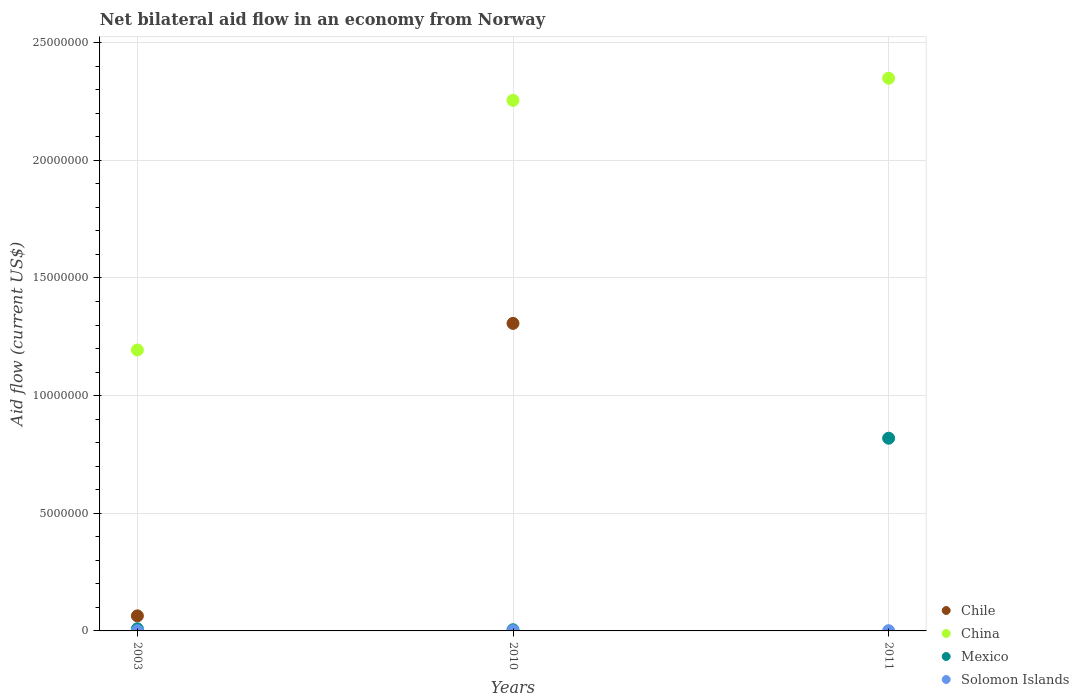Is the number of dotlines equal to the number of legend labels?
Make the answer very short. No. What is the net bilateral aid flow in Solomon Islands in 2003?
Offer a terse response. 10000. Across all years, what is the minimum net bilateral aid flow in Solomon Islands?
Ensure brevity in your answer.  10000. In which year was the net bilateral aid flow in China maximum?
Make the answer very short. 2011. What is the total net bilateral aid flow in China in the graph?
Provide a short and direct response. 5.80e+07. What is the difference between the net bilateral aid flow in China in 2011 and the net bilateral aid flow in Mexico in 2003?
Offer a very short reply. 2.34e+07. What is the average net bilateral aid flow in Solomon Islands per year?
Provide a succinct answer. 10000. What is the ratio of the net bilateral aid flow in Solomon Islands in 2003 to that in 2010?
Keep it short and to the point. 1. What is the difference between the highest and the lowest net bilateral aid flow in Chile?
Offer a very short reply. 1.31e+07. In how many years, is the net bilateral aid flow in Chile greater than the average net bilateral aid flow in Chile taken over all years?
Give a very brief answer. 1. Is the sum of the net bilateral aid flow in Chile in 2003 and 2010 greater than the maximum net bilateral aid flow in Mexico across all years?
Provide a short and direct response. Yes. Is it the case that in every year, the sum of the net bilateral aid flow in China and net bilateral aid flow in Solomon Islands  is greater than the sum of net bilateral aid flow in Mexico and net bilateral aid flow in Chile?
Your answer should be very brief. Yes. Is it the case that in every year, the sum of the net bilateral aid flow in Mexico and net bilateral aid flow in Solomon Islands  is greater than the net bilateral aid flow in China?
Make the answer very short. No. Is the net bilateral aid flow in Mexico strictly greater than the net bilateral aid flow in China over the years?
Offer a very short reply. No. How many dotlines are there?
Your answer should be very brief. 4. What is the difference between two consecutive major ticks on the Y-axis?
Keep it short and to the point. 5.00e+06. Where does the legend appear in the graph?
Ensure brevity in your answer.  Bottom right. How are the legend labels stacked?
Make the answer very short. Vertical. What is the title of the graph?
Your response must be concise. Net bilateral aid flow in an economy from Norway. What is the label or title of the X-axis?
Offer a very short reply. Years. What is the label or title of the Y-axis?
Provide a succinct answer. Aid flow (current US$). What is the Aid flow (current US$) of Chile in 2003?
Your response must be concise. 6.40e+05. What is the Aid flow (current US$) in China in 2003?
Keep it short and to the point. 1.19e+07. What is the Aid flow (current US$) of Chile in 2010?
Give a very brief answer. 1.31e+07. What is the Aid flow (current US$) in China in 2010?
Your answer should be very brief. 2.26e+07. What is the Aid flow (current US$) in Mexico in 2010?
Offer a very short reply. 5.00e+04. What is the Aid flow (current US$) of China in 2011?
Keep it short and to the point. 2.35e+07. What is the Aid flow (current US$) in Mexico in 2011?
Make the answer very short. 8.19e+06. What is the Aid flow (current US$) in Solomon Islands in 2011?
Ensure brevity in your answer.  10000. Across all years, what is the maximum Aid flow (current US$) of Chile?
Offer a terse response. 1.31e+07. Across all years, what is the maximum Aid flow (current US$) of China?
Give a very brief answer. 2.35e+07. Across all years, what is the maximum Aid flow (current US$) in Mexico?
Offer a very short reply. 8.19e+06. Across all years, what is the maximum Aid flow (current US$) in Solomon Islands?
Your answer should be compact. 10000. Across all years, what is the minimum Aid flow (current US$) of China?
Offer a very short reply. 1.19e+07. Across all years, what is the minimum Aid flow (current US$) in Solomon Islands?
Your response must be concise. 10000. What is the total Aid flow (current US$) of Chile in the graph?
Ensure brevity in your answer.  1.37e+07. What is the total Aid flow (current US$) of China in the graph?
Provide a short and direct response. 5.80e+07. What is the total Aid flow (current US$) of Mexico in the graph?
Give a very brief answer. 8.33e+06. What is the total Aid flow (current US$) in Solomon Islands in the graph?
Offer a terse response. 3.00e+04. What is the difference between the Aid flow (current US$) of Chile in 2003 and that in 2010?
Provide a succinct answer. -1.24e+07. What is the difference between the Aid flow (current US$) of China in 2003 and that in 2010?
Your response must be concise. -1.06e+07. What is the difference between the Aid flow (current US$) in Solomon Islands in 2003 and that in 2010?
Provide a short and direct response. 0. What is the difference between the Aid flow (current US$) in China in 2003 and that in 2011?
Your answer should be very brief. -1.16e+07. What is the difference between the Aid flow (current US$) of Mexico in 2003 and that in 2011?
Offer a very short reply. -8.10e+06. What is the difference between the Aid flow (current US$) in China in 2010 and that in 2011?
Your answer should be very brief. -9.40e+05. What is the difference between the Aid flow (current US$) in Mexico in 2010 and that in 2011?
Give a very brief answer. -8.14e+06. What is the difference between the Aid flow (current US$) in Solomon Islands in 2010 and that in 2011?
Offer a terse response. 0. What is the difference between the Aid flow (current US$) in Chile in 2003 and the Aid flow (current US$) in China in 2010?
Provide a succinct answer. -2.19e+07. What is the difference between the Aid flow (current US$) of Chile in 2003 and the Aid flow (current US$) of Mexico in 2010?
Offer a very short reply. 5.90e+05. What is the difference between the Aid flow (current US$) of Chile in 2003 and the Aid flow (current US$) of Solomon Islands in 2010?
Your answer should be very brief. 6.30e+05. What is the difference between the Aid flow (current US$) in China in 2003 and the Aid flow (current US$) in Mexico in 2010?
Your answer should be compact. 1.19e+07. What is the difference between the Aid flow (current US$) of China in 2003 and the Aid flow (current US$) of Solomon Islands in 2010?
Your response must be concise. 1.19e+07. What is the difference between the Aid flow (current US$) in Mexico in 2003 and the Aid flow (current US$) in Solomon Islands in 2010?
Offer a very short reply. 8.00e+04. What is the difference between the Aid flow (current US$) in Chile in 2003 and the Aid flow (current US$) in China in 2011?
Give a very brief answer. -2.28e+07. What is the difference between the Aid flow (current US$) of Chile in 2003 and the Aid flow (current US$) of Mexico in 2011?
Keep it short and to the point. -7.55e+06. What is the difference between the Aid flow (current US$) of Chile in 2003 and the Aid flow (current US$) of Solomon Islands in 2011?
Ensure brevity in your answer.  6.30e+05. What is the difference between the Aid flow (current US$) of China in 2003 and the Aid flow (current US$) of Mexico in 2011?
Your answer should be compact. 3.75e+06. What is the difference between the Aid flow (current US$) of China in 2003 and the Aid flow (current US$) of Solomon Islands in 2011?
Keep it short and to the point. 1.19e+07. What is the difference between the Aid flow (current US$) of Mexico in 2003 and the Aid flow (current US$) of Solomon Islands in 2011?
Offer a very short reply. 8.00e+04. What is the difference between the Aid flow (current US$) of Chile in 2010 and the Aid flow (current US$) of China in 2011?
Give a very brief answer. -1.04e+07. What is the difference between the Aid flow (current US$) of Chile in 2010 and the Aid flow (current US$) of Mexico in 2011?
Keep it short and to the point. 4.88e+06. What is the difference between the Aid flow (current US$) of Chile in 2010 and the Aid flow (current US$) of Solomon Islands in 2011?
Give a very brief answer. 1.31e+07. What is the difference between the Aid flow (current US$) in China in 2010 and the Aid flow (current US$) in Mexico in 2011?
Provide a succinct answer. 1.44e+07. What is the difference between the Aid flow (current US$) of China in 2010 and the Aid flow (current US$) of Solomon Islands in 2011?
Your answer should be very brief. 2.25e+07. What is the difference between the Aid flow (current US$) of Mexico in 2010 and the Aid flow (current US$) of Solomon Islands in 2011?
Ensure brevity in your answer.  4.00e+04. What is the average Aid flow (current US$) in Chile per year?
Your answer should be compact. 4.57e+06. What is the average Aid flow (current US$) in China per year?
Your answer should be very brief. 1.93e+07. What is the average Aid flow (current US$) of Mexico per year?
Your answer should be very brief. 2.78e+06. What is the average Aid flow (current US$) of Solomon Islands per year?
Provide a succinct answer. 10000. In the year 2003, what is the difference between the Aid flow (current US$) in Chile and Aid flow (current US$) in China?
Provide a succinct answer. -1.13e+07. In the year 2003, what is the difference between the Aid flow (current US$) of Chile and Aid flow (current US$) of Solomon Islands?
Keep it short and to the point. 6.30e+05. In the year 2003, what is the difference between the Aid flow (current US$) of China and Aid flow (current US$) of Mexico?
Provide a short and direct response. 1.18e+07. In the year 2003, what is the difference between the Aid flow (current US$) of China and Aid flow (current US$) of Solomon Islands?
Keep it short and to the point. 1.19e+07. In the year 2003, what is the difference between the Aid flow (current US$) of Mexico and Aid flow (current US$) of Solomon Islands?
Offer a very short reply. 8.00e+04. In the year 2010, what is the difference between the Aid flow (current US$) in Chile and Aid flow (current US$) in China?
Provide a succinct answer. -9.48e+06. In the year 2010, what is the difference between the Aid flow (current US$) of Chile and Aid flow (current US$) of Mexico?
Give a very brief answer. 1.30e+07. In the year 2010, what is the difference between the Aid flow (current US$) of Chile and Aid flow (current US$) of Solomon Islands?
Ensure brevity in your answer.  1.31e+07. In the year 2010, what is the difference between the Aid flow (current US$) of China and Aid flow (current US$) of Mexico?
Your answer should be compact. 2.25e+07. In the year 2010, what is the difference between the Aid flow (current US$) of China and Aid flow (current US$) of Solomon Islands?
Offer a terse response. 2.25e+07. In the year 2010, what is the difference between the Aid flow (current US$) of Mexico and Aid flow (current US$) of Solomon Islands?
Your answer should be compact. 4.00e+04. In the year 2011, what is the difference between the Aid flow (current US$) of China and Aid flow (current US$) of Mexico?
Your response must be concise. 1.53e+07. In the year 2011, what is the difference between the Aid flow (current US$) in China and Aid flow (current US$) in Solomon Islands?
Ensure brevity in your answer.  2.35e+07. In the year 2011, what is the difference between the Aid flow (current US$) in Mexico and Aid flow (current US$) in Solomon Islands?
Provide a succinct answer. 8.18e+06. What is the ratio of the Aid flow (current US$) of Chile in 2003 to that in 2010?
Your answer should be compact. 0.05. What is the ratio of the Aid flow (current US$) of China in 2003 to that in 2010?
Provide a short and direct response. 0.53. What is the ratio of the Aid flow (current US$) of China in 2003 to that in 2011?
Ensure brevity in your answer.  0.51. What is the ratio of the Aid flow (current US$) in Mexico in 2003 to that in 2011?
Provide a short and direct response. 0.01. What is the ratio of the Aid flow (current US$) in China in 2010 to that in 2011?
Your response must be concise. 0.96. What is the ratio of the Aid flow (current US$) in Mexico in 2010 to that in 2011?
Provide a short and direct response. 0.01. What is the ratio of the Aid flow (current US$) in Solomon Islands in 2010 to that in 2011?
Make the answer very short. 1. What is the difference between the highest and the second highest Aid flow (current US$) in China?
Offer a terse response. 9.40e+05. What is the difference between the highest and the second highest Aid flow (current US$) of Mexico?
Make the answer very short. 8.10e+06. What is the difference between the highest and the second highest Aid flow (current US$) of Solomon Islands?
Your response must be concise. 0. What is the difference between the highest and the lowest Aid flow (current US$) in Chile?
Provide a short and direct response. 1.31e+07. What is the difference between the highest and the lowest Aid flow (current US$) of China?
Provide a short and direct response. 1.16e+07. What is the difference between the highest and the lowest Aid flow (current US$) of Mexico?
Ensure brevity in your answer.  8.14e+06. 